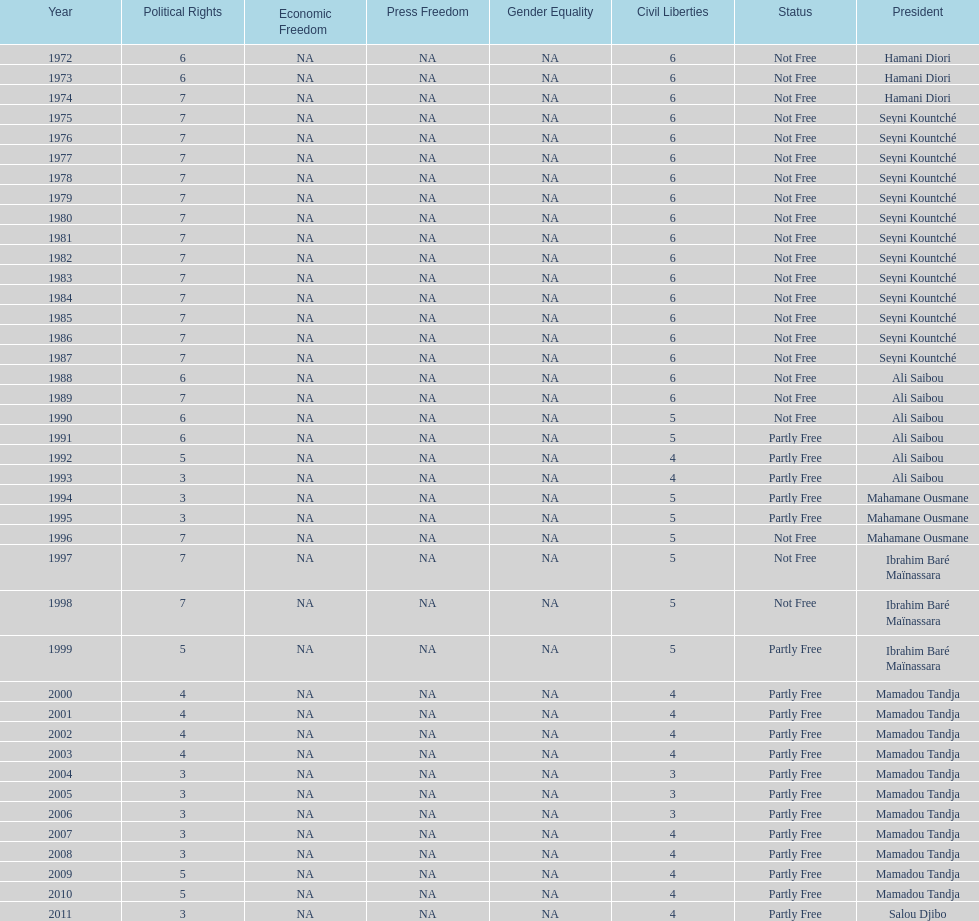How many years was ali saibou president? 6. 